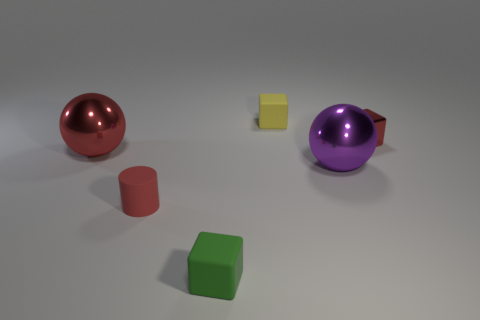What is the material of the big thing that is in front of the red metallic thing that is to the left of the tiny metallic block?
Keep it short and to the point. Metal. Is the size of the block that is on the left side of the yellow matte cube the same as the large red ball?
Make the answer very short. No. Is there a metal sphere of the same color as the tiny metal object?
Your answer should be compact. Yes. What number of objects are things that are right of the large red metallic object or big spheres that are left of the purple thing?
Offer a terse response. 6. Do the tiny metallic thing and the matte cylinder have the same color?
Your response must be concise. Yes. What material is the tiny object that is the same color as the cylinder?
Your response must be concise. Metal. Is the number of shiny cubes that are on the left side of the red metallic sphere less than the number of green rubber cubes right of the large purple shiny ball?
Provide a short and direct response. No. Is the green block made of the same material as the purple thing?
Provide a short and direct response. No. What size is the metallic thing that is both on the left side of the shiny block and to the right of the red matte cylinder?
Give a very brief answer. Large. There is a red metallic thing that is the same size as the yellow block; what shape is it?
Offer a very short reply. Cube. 